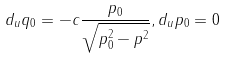<formula> <loc_0><loc_0><loc_500><loc_500>d _ { u } q _ { 0 } = - c \frac { p _ { 0 } } { \sqrt { p _ { 0 } ^ { 2 } - { p } ^ { 2 } } } , d _ { u } p _ { 0 } = 0</formula> 